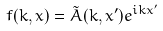Convert formula to latex. <formula><loc_0><loc_0><loc_500><loc_500>f ( k , x ) = \tilde { A } ( k , x ^ { \prime } ) e ^ { i k x ^ { \prime } }</formula> 